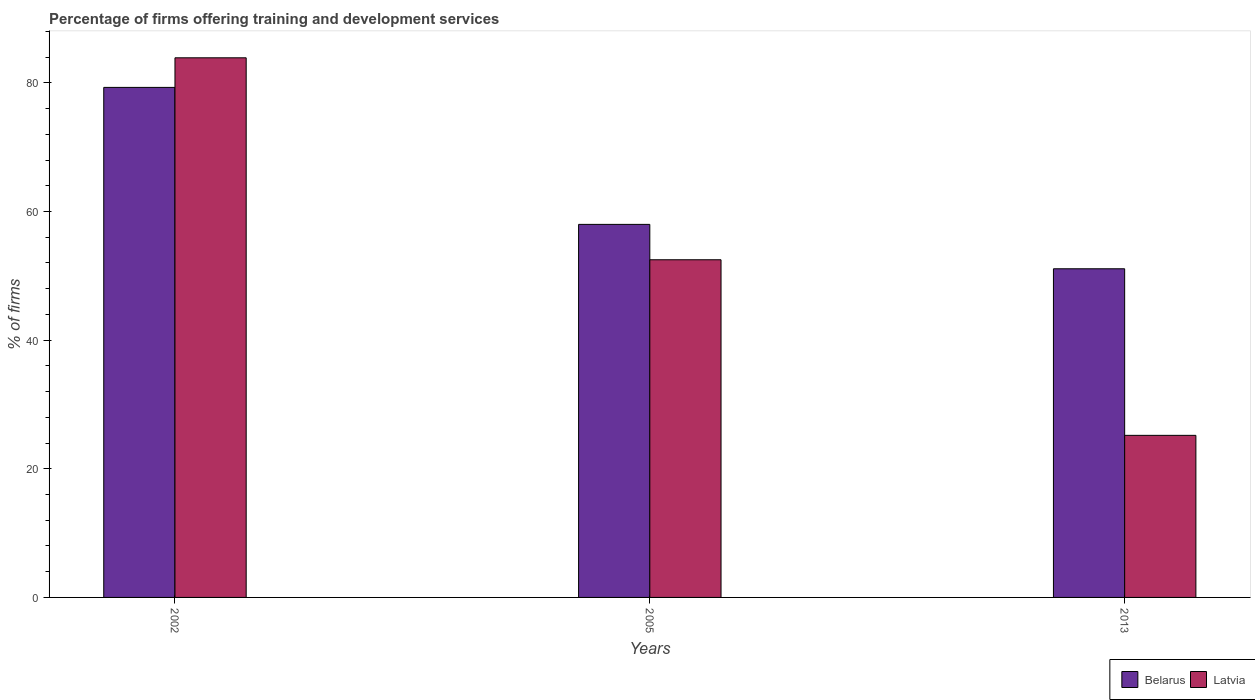Are the number of bars per tick equal to the number of legend labels?
Offer a terse response. Yes. How many bars are there on the 3rd tick from the left?
Keep it short and to the point. 2. How many bars are there on the 2nd tick from the right?
Give a very brief answer. 2. What is the label of the 2nd group of bars from the left?
Your answer should be very brief. 2005. In how many cases, is the number of bars for a given year not equal to the number of legend labels?
Make the answer very short. 0. What is the percentage of firms offering training and development in Belarus in 2002?
Your answer should be very brief. 79.3. Across all years, what is the maximum percentage of firms offering training and development in Belarus?
Your response must be concise. 79.3. Across all years, what is the minimum percentage of firms offering training and development in Belarus?
Offer a terse response. 51.1. In which year was the percentage of firms offering training and development in Belarus minimum?
Keep it short and to the point. 2013. What is the total percentage of firms offering training and development in Belarus in the graph?
Offer a terse response. 188.4. What is the difference between the percentage of firms offering training and development in Latvia in 2005 and that in 2013?
Your answer should be very brief. 27.3. What is the difference between the percentage of firms offering training and development in Belarus in 2002 and the percentage of firms offering training and development in Latvia in 2013?
Give a very brief answer. 54.1. What is the average percentage of firms offering training and development in Belarus per year?
Provide a short and direct response. 62.8. In how many years, is the percentage of firms offering training and development in Latvia greater than 68 %?
Give a very brief answer. 1. What is the ratio of the percentage of firms offering training and development in Latvia in 2002 to that in 2013?
Ensure brevity in your answer.  3.33. Is the percentage of firms offering training and development in Belarus in 2005 less than that in 2013?
Your answer should be very brief. No. What is the difference between the highest and the second highest percentage of firms offering training and development in Belarus?
Ensure brevity in your answer.  21.3. What is the difference between the highest and the lowest percentage of firms offering training and development in Belarus?
Offer a terse response. 28.2. In how many years, is the percentage of firms offering training and development in Belarus greater than the average percentage of firms offering training and development in Belarus taken over all years?
Your answer should be very brief. 1. What does the 1st bar from the left in 2005 represents?
Provide a short and direct response. Belarus. What does the 2nd bar from the right in 2005 represents?
Give a very brief answer. Belarus. How many bars are there?
Provide a short and direct response. 6. How many years are there in the graph?
Offer a very short reply. 3. Does the graph contain any zero values?
Give a very brief answer. No. Does the graph contain grids?
Make the answer very short. No. Where does the legend appear in the graph?
Provide a succinct answer. Bottom right. What is the title of the graph?
Provide a short and direct response. Percentage of firms offering training and development services. What is the label or title of the Y-axis?
Your response must be concise. % of firms. What is the % of firms in Belarus in 2002?
Your answer should be very brief. 79.3. What is the % of firms in Latvia in 2002?
Keep it short and to the point. 83.9. What is the % of firms in Belarus in 2005?
Provide a short and direct response. 58. What is the % of firms of Latvia in 2005?
Your answer should be very brief. 52.5. What is the % of firms in Belarus in 2013?
Offer a very short reply. 51.1. What is the % of firms of Latvia in 2013?
Keep it short and to the point. 25.2. Across all years, what is the maximum % of firms of Belarus?
Offer a very short reply. 79.3. Across all years, what is the maximum % of firms in Latvia?
Your response must be concise. 83.9. Across all years, what is the minimum % of firms of Belarus?
Your response must be concise. 51.1. Across all years, what is the minimum % of firms in Latvia?
Offer a terse response. 25.2. What is the total % of firms of Belarus in the graph?
Your response must be concise. 188.4. What is the total % of firms of Latvia in the graph?
Provide a short and direct response. 161.6. What is the difference between the % of firms of Belarus in 2002 and that in 2005?
Offer a very short reply. 21.3. What is the difference between the % of firms of Latvia in 2002 and that in 2005?
Your response must be concise. 31.4. What is the difference between the % of firms in Belarus in 2002 and that in 2013?
Your answer should be compact. 28.2. What is the difference between the % of firms of Latvia in 2002 and that in 2013?
Make the answer very short. 58.7. What is the difference between the % of firms of Latvia in 2005 and that in 2013?
Offer a terse response. 27.3. What is the difference between the % of firms of Belarus in 2002 and the % of firms of Latvia in 2005?
Ensure brevity in your answer.  26.8. What is the difference between the % of firms of Belarus in 2002 and the % of firms of Latvia in 2013?
Provide a short and direct response. 54.1. What is the difference between the % of firms of Belarus in 2005 and the % of firms of Latvia in 2013?
Your answer should be very brief. 32.8. What is the average % of firms of Belarus per year?
Make the answer very short. 62.8. What is the average % of firms of Latvia per year?
Ensure brevity in your answer.  53.87. In the year 2002, what is the difference between the % of firms of Belarus and % of firms of Latvia?
Your answer should be very brief. -4.6. In the year 2013, what is the difference between the % of firms of Belarus and % of firms of Latvia?
Your answer should be compact. 25.9. What is the ratio of the % of firms in Belarus in 2002 to that in 2005?
Your response must be concise. 1.37. What is the ratio of the % of firms of Latvia in 2002 to that in 2005?
Keep it short and to the point. 1.6. What is the ratio of the % of firms in Belarus in 2002 to that in 2013?
Your answer should be compact. 1.55. What is the ratio of the % of firms of Latvia in 2002 to that in 2013?
Your answer should be very brief. 3.33. What is the ratio of the % of firms of Belarus in 2005 to that in 2013?
Your answer should be compact. 1.14. What is the ratio of the % of firms in Latvia in 2005 to that in 2013?
Keep it short and to the point. 2.08. What is the difference between the highest and the second highest % of firms in Belarus?
Keep it short and to the point. 21.3. What is the difference between the highest and the second highest % of firms of Latvia?
Your answer should be compact. 31.4. What is the difference between the highest and the lowest % of firms in Belarus?
Give a very brief answer. 28.2. What is the difference between the highest and the lowest % of firms in Latvia?
Ensure brevity in your answer.  58.7. 